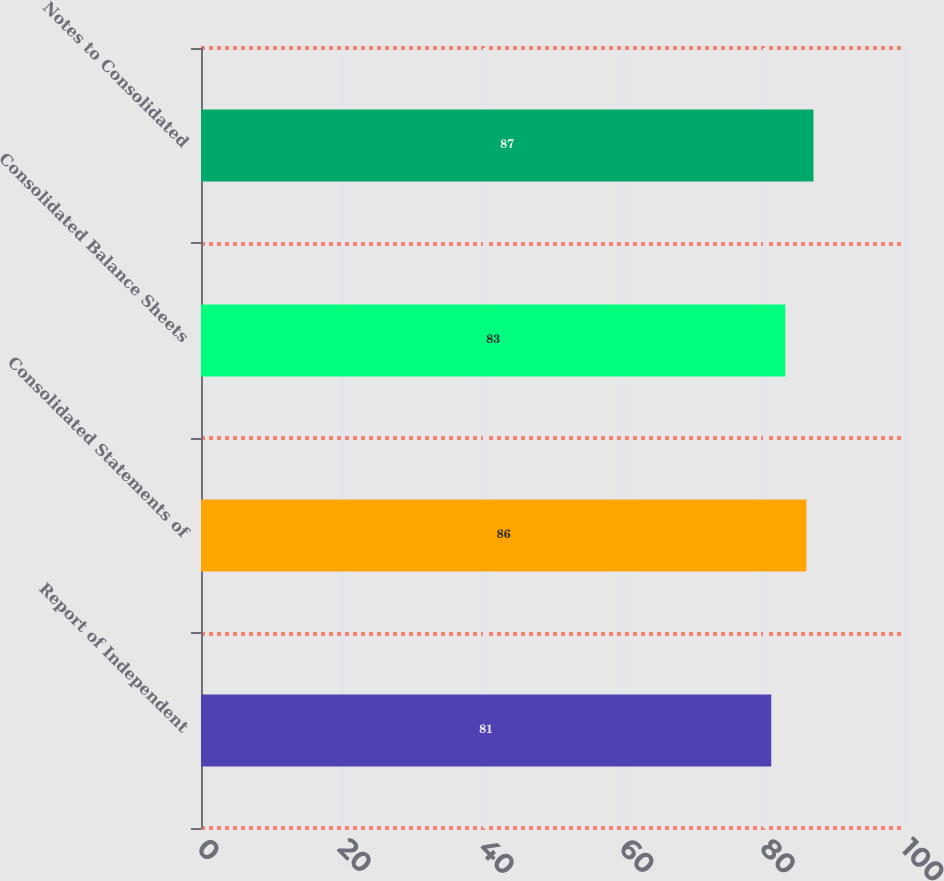Convert chart to OTSL. <chart><loc_0><loc_0><loc_500><loc_500><bar_chart><fcel>Report of Independent<fcel>Consolidated Statements of<fcel>Consolidated Balance Sheets<fcel>Notes to Consolidated<nl><fcel>81<fcel>86<fcel>83<fcel>87<nl></chart> 